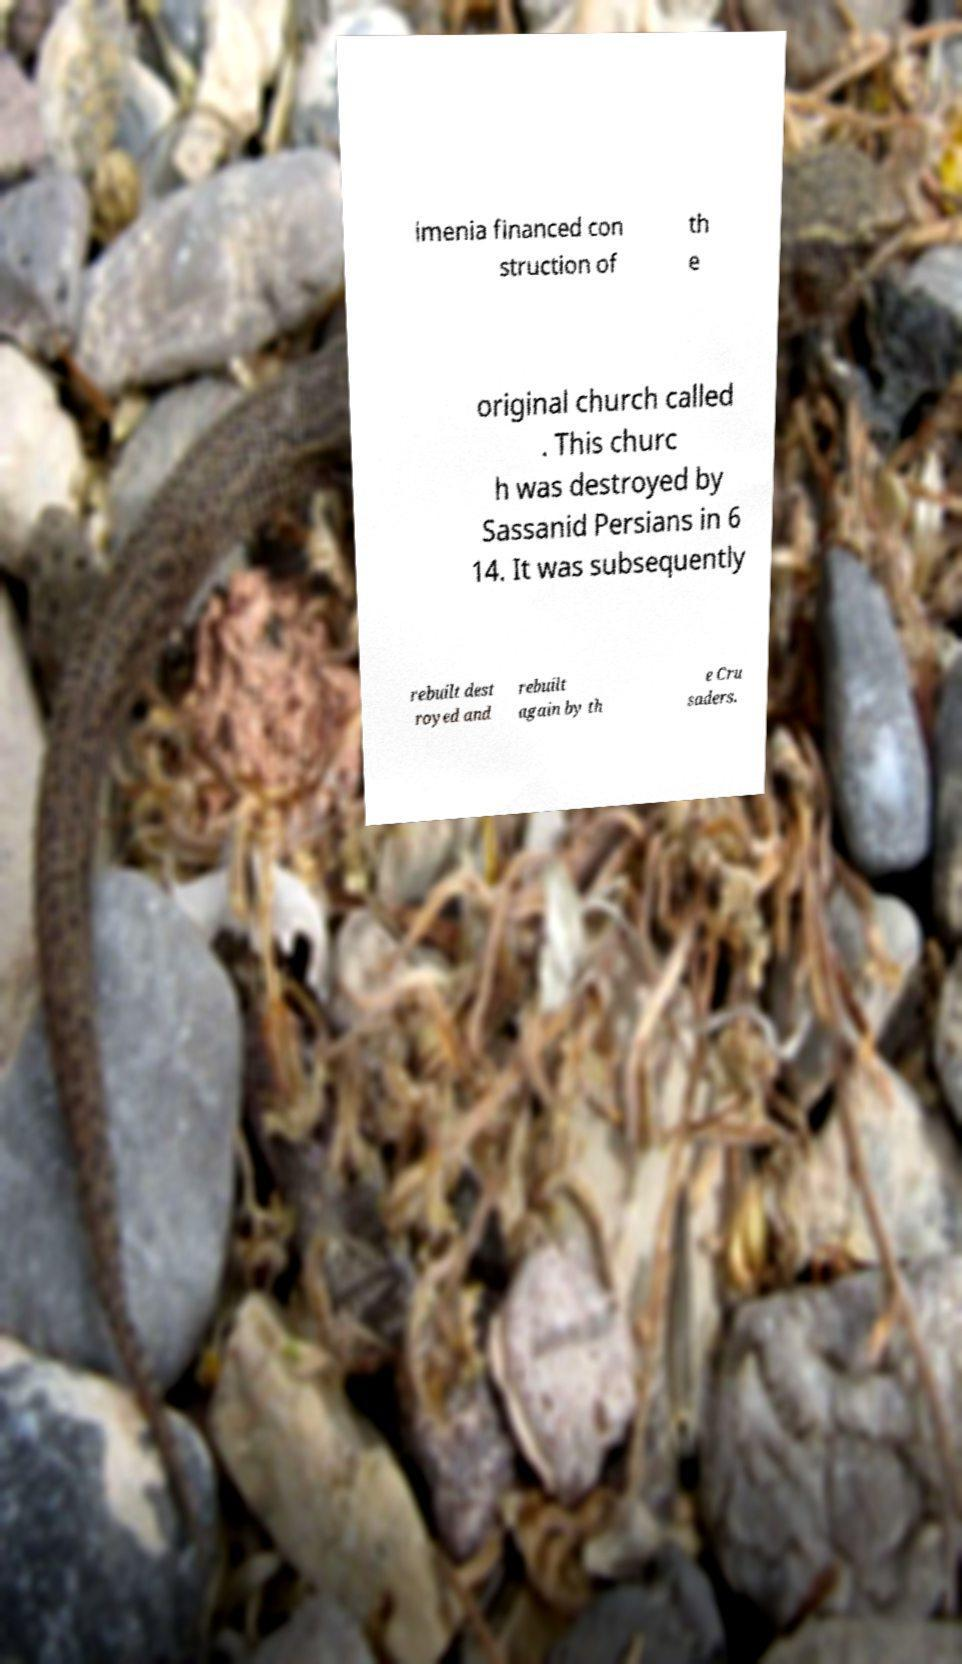Can you read and provide the text displayed in the image?This photo seems to have some interesting text. Can you extract and type it out for me? imenia financed con struction of th e original church called . This churc h was destroyed by Sassanid Persians in 6 14. It was subsequently rebuilt dest royed and rebuilt again by th e Cru saders. 